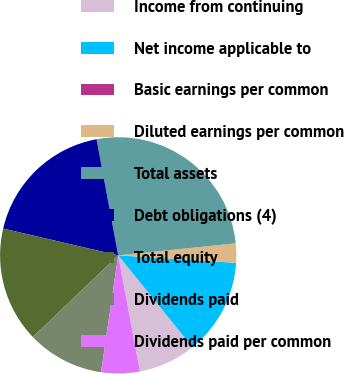<chart> <loc_0><loc_0><loc_500><loc_500><pie_chart><fcel>Income from continuing<fcel>Net income applicable to<fcel>Basic earnings per common<fcel>Diluted earnings per common<fcel>Total assets<fcel>Debt obligations (4)<fcel>Total equity<fcel>Dividends paid<fcel>Dividends paid per common<nl><fcel>7.89%<fcel>13.16%<fcel>0.0%<fcel>2.63%<fcel>26.32%<fcel>18.42%<fcel>15.79%<fcel>10.53%<fcel>5.26%<nl></chart> 